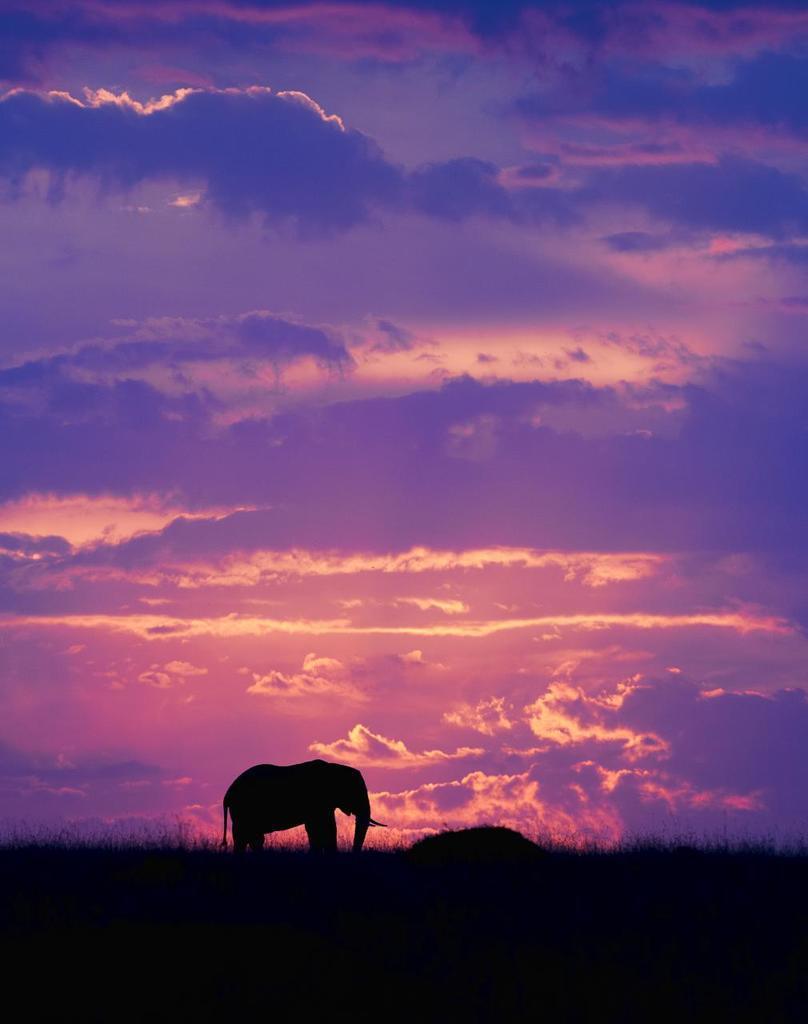Could you give a brief overview of what you see in this image? In the center of the image there is a elephant. At the bottom of the image there is grass. At the top of the image there is sky and clouds. 